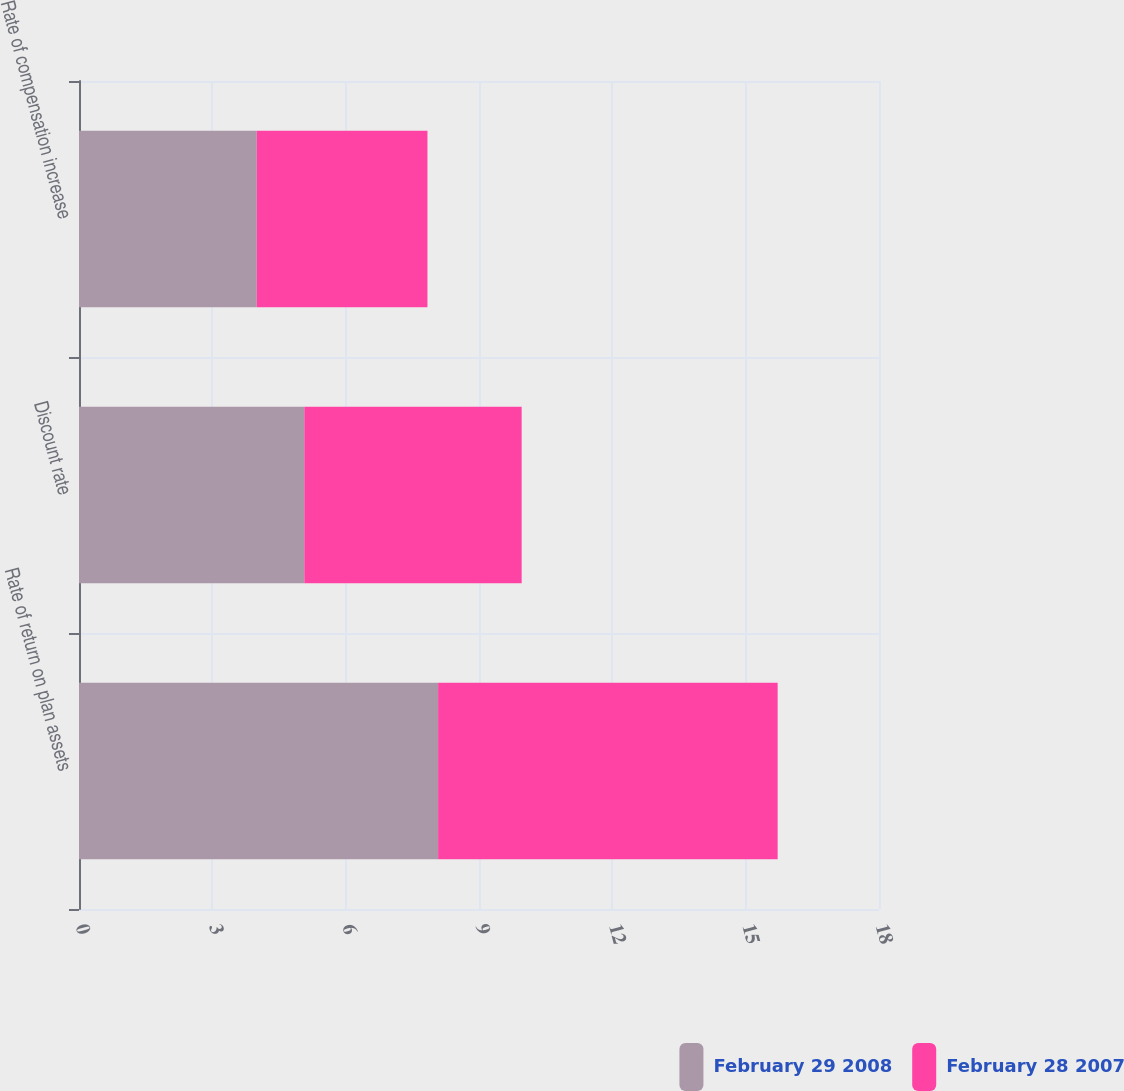<chart> <loc_0><loc_0><loc_500><loc_500><stacked_bar_chart><ecel><fcel>Rate of return on plan assets<fcel>Discount rate<fcel>Rate of compensation increase<nl><fcel>February 29 2008<fcel>8.08<fcel>5.07<fcel>4<nl><fcel>February 28 2007<fcel>7.64<fcel>4.89<fcel>3.84<nl></chart> 